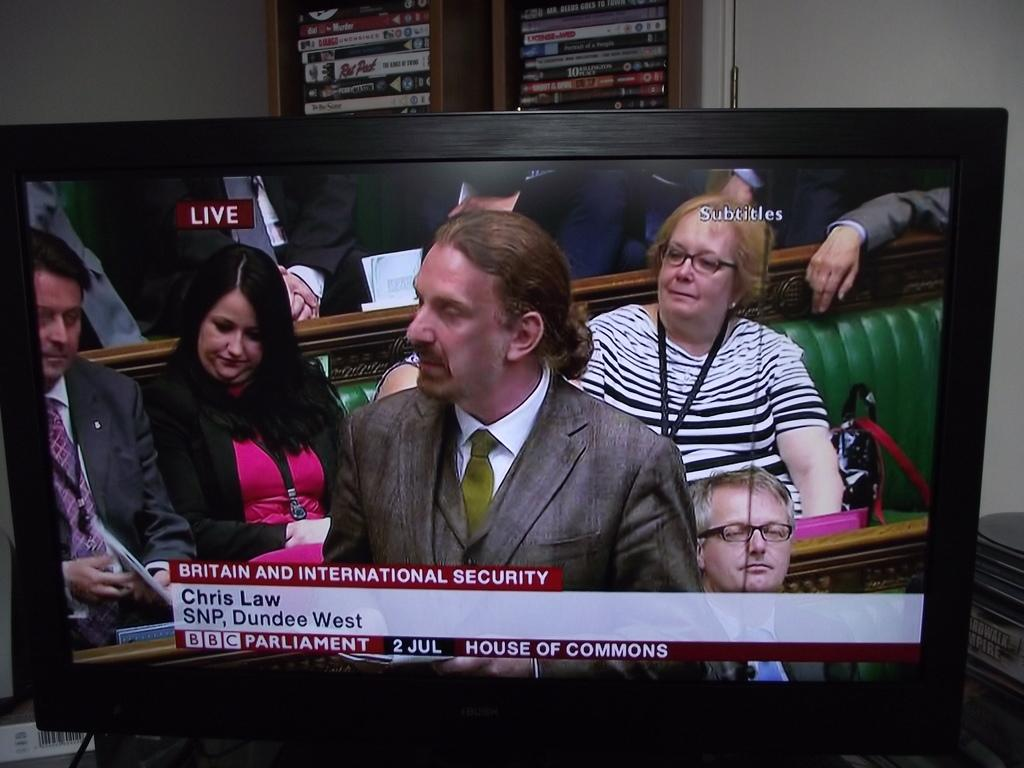<image>
Write a terse but informative summary of the picture. a Chris Law name with Britain Security on it 